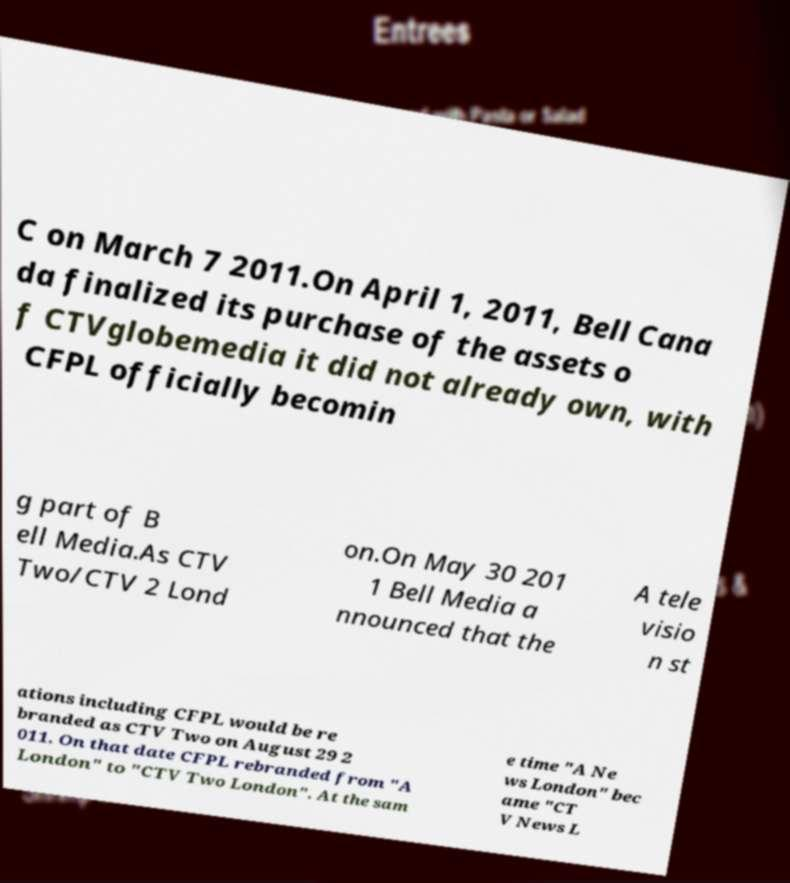Could you assist in decoding the text presented in this image and type it out clearly? C on March 7 2011.On April 1, 2011, Bell Cana da finalized its purchase of the assets o f CTVglobemedia it did not already own, with CFPL officially becomin g part of B ell Media.As CTV Two/CTV 2 Lond on.On May 30 201 1 Bell Media a nnounced that the A tele visio n st ations including CFPL would be re branded as CTV Two on August 29 2 011. On that date CFPL rebranded from "A London" to "CTV Two London". At the sam e time "A Ne ws London" bec ame "CT V News L 